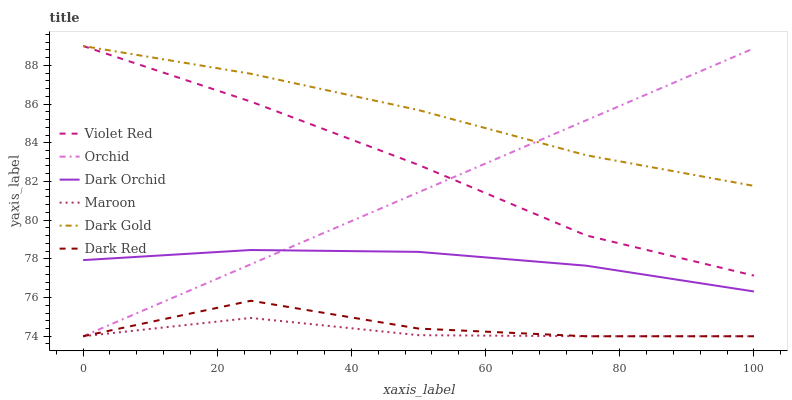Does Maroon have the minimum area under the curve?
Answer yes or no. Yes. Does Dark Gold have the maximum area under the curve?
Answer yes or no. Yes. Does Dark Red have the minimum area under the curve?
Answer yes or no. No. Does Dark Red have the maximum area under the curve?
Answer yes or no. No. Is Orchid the smoothest?
Answer yes or no. Yes. Is Dark Red the roughest?
Answer yes or no. Yes. Is Dark Gold the smoothest?
Answer yes or no. No. Is Dark Gold the roughest?
Answer yes or no. No. Does Dark Gold have the lowest value?
Answer yes or no. No. Does Dark Gold have the highest value?
Answer yes or no. Yes. Does Dark Red have the highest value?
Answer yes or no. No. Is Dark Orchid less than Dark Gold?
Answer yes or no. Yes. Is Dark Gold greater than Dark Orchid?
Answer yes or no. Yes. Does Dark Orchid intersect Orchid?
Answer yes or no. Yes. Is Dark Orchid less than Orchid?
Answer yes or no. No. Is Dark Orchid greater than Orchid?
Answer yes or no. No. Does Dark Orchid intersect Dark Gold?
Answer yes or no. No. 